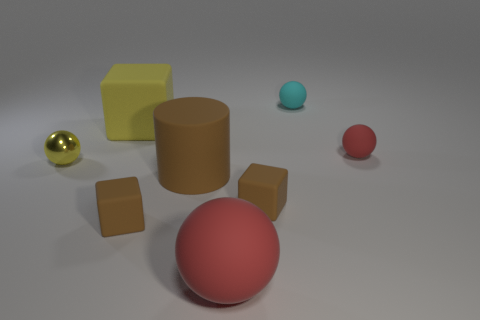There is a shiny object that is the same color as the large rubber block; what size is it?
Ensure brevity in your answer.  Small. Is there any other thing that is made of the same material as the tiny yellow sphere?
Your answer should be compact. No. What is the shape of the tiny red thing that is the same material as the big yellow cube?
Provide a succinct answer. Sphere. Are there more small brown matte things left of the brown rubber cylinder than tiny red shiny objects?
Your answer should be compact. Yes. What is the material of the small cyan thing?
Keep it short and to the point. Rubber. How many brown matte objects have the same size as the cyan rubber object?
Your response must be concise. 2. Are there the same number of matte blocks that are behind the tiny yellow shiny ball and large things behind the tiny red object?
Offer a very short reply. Yes. Do the large cylinder and the big block have the same material?
Give a very brief answer. Yes. Is there a matte cube right of the tiny ball that is to the left of the large rubber cube?
Give a very brief answer. Yes. Are there any rubber objects that have the same shape as the yellow shiny thing?
Provide a short and direct response. Yes. 